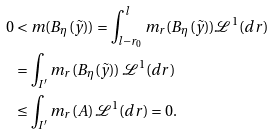<formula> <loc_0><loc_0><loc_500><loc_500>0 & < m ( B _ { \eta } ( \tilde { y } ) ) = \int _ { l - r _ { 0 } } ^ { l } m _ { r } ( B _ { \eta } ( \tilde { y } ) ) \mathcal { L } ^ { 1 } ( d r ) \\ & = \int _ { I ^ { \prime } } m _ { r } ( B _ { \eta } ( \tilde { y } ) ) \, \mathcal { L } ^ { 1 } ( d r ) \\ & \leq \int _ { I ^ { \prime } } m _ { r } ( A ) \, \mathcal { L } ^ { 1 } ( d r ) = 0 .</formula> 